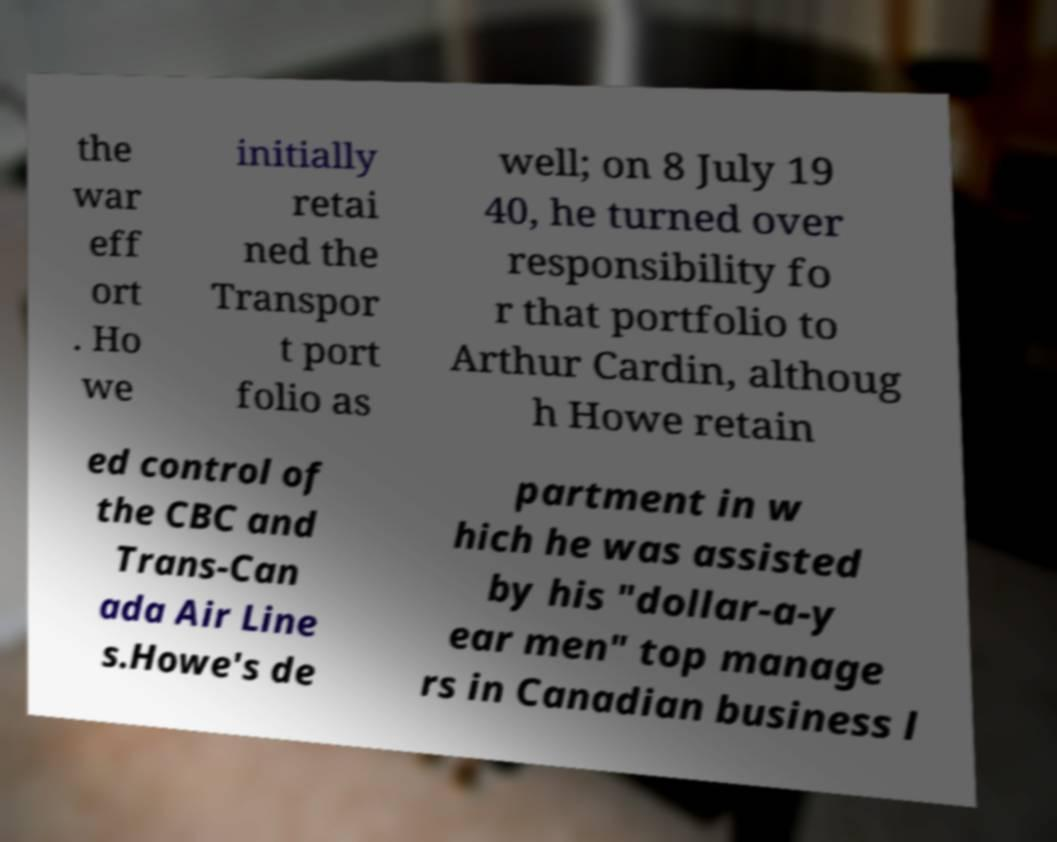Can you accurately transcribe the text from the provided image for me? the war eff ort . Ho we initially retai ned the Transpor t port folio as well; on 8 July 19 40, he turned over responsibility fo r that portfolio to Arthur Cardin, althoug h Howe retain ed control of the CBC and Trans-Can ada Air Line s.Howe's de partment in w hich he was assisted by his "dollar-a-y ear men" top manage rs in Canadian business l 